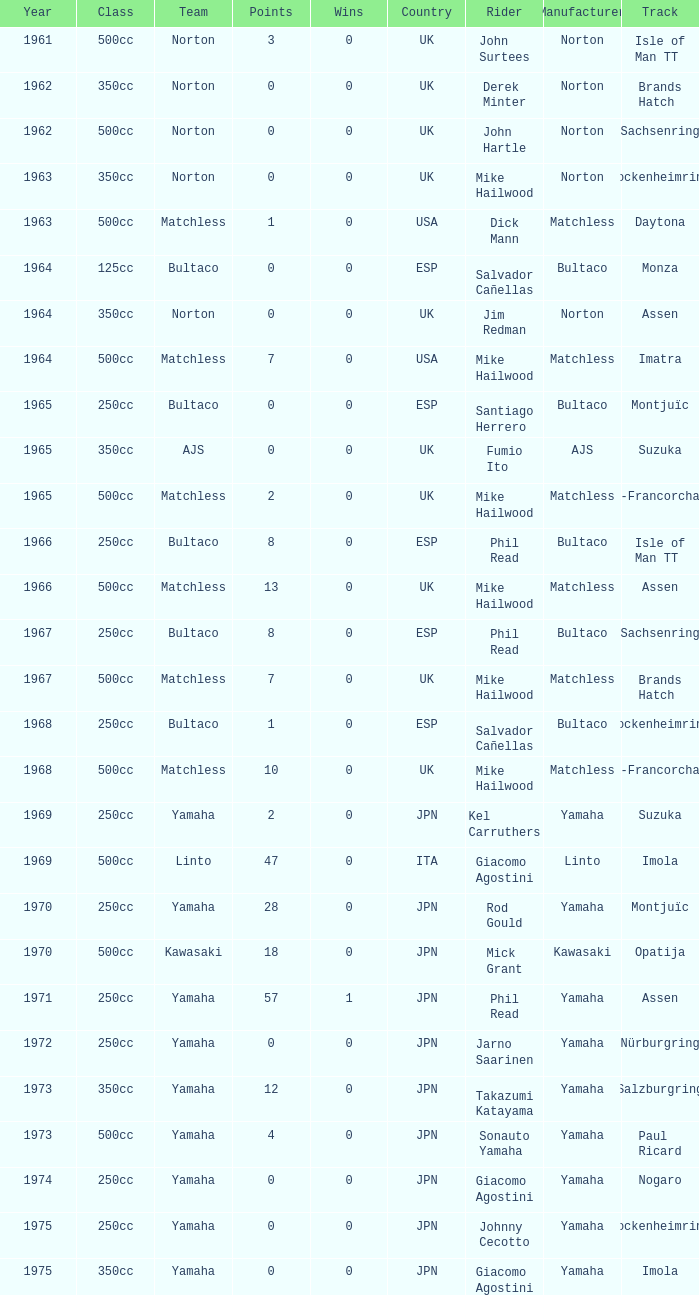What is the average wins in 250cc class for Bultaco with 8 points later than 1966? 0.0. 